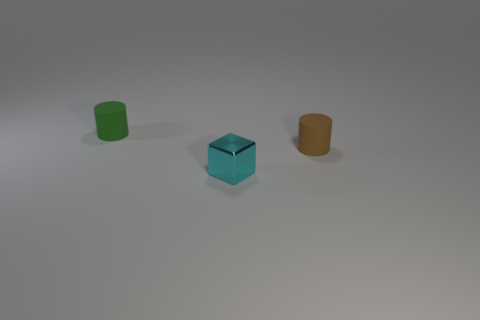There is a rubber cylinder that is in front of the green thing; is its size the same as the small shiny object?
Provide a short and direct response. Yes. What color is the tiny thing that is behind the small cyan thing and to the right of the small green matte cylinder?
Provide a short and direct response. Brown. There is a small matte cylinder that is on the right side of the tiny green rubber object; how many small blocks are in front of it?
Make the answer very short. 1. Does the small brown thing have the same shape as the green object?
Offer a very short reply. Yes. Is there anything else of the same color as the block?
Make the answer very short. No. Do the small green thing and the small object on the right side of the cube have the same shape?
Offer a very short reply. Yes. What color is the matte thing right of the small object behind the tiny brown matte cylinder behind the cyan block?
Make the answer very short. Brown. Is there anything else that is the same material as the green cylinder?
Your answer should be very brief. Yes. There is a small thing that is in front of the small brown rubber cylinder; is its shape the same as the green object?
Your answer should be very brief. No. What material is the small brown cylinder?
Offer a terse response. Rubber. 